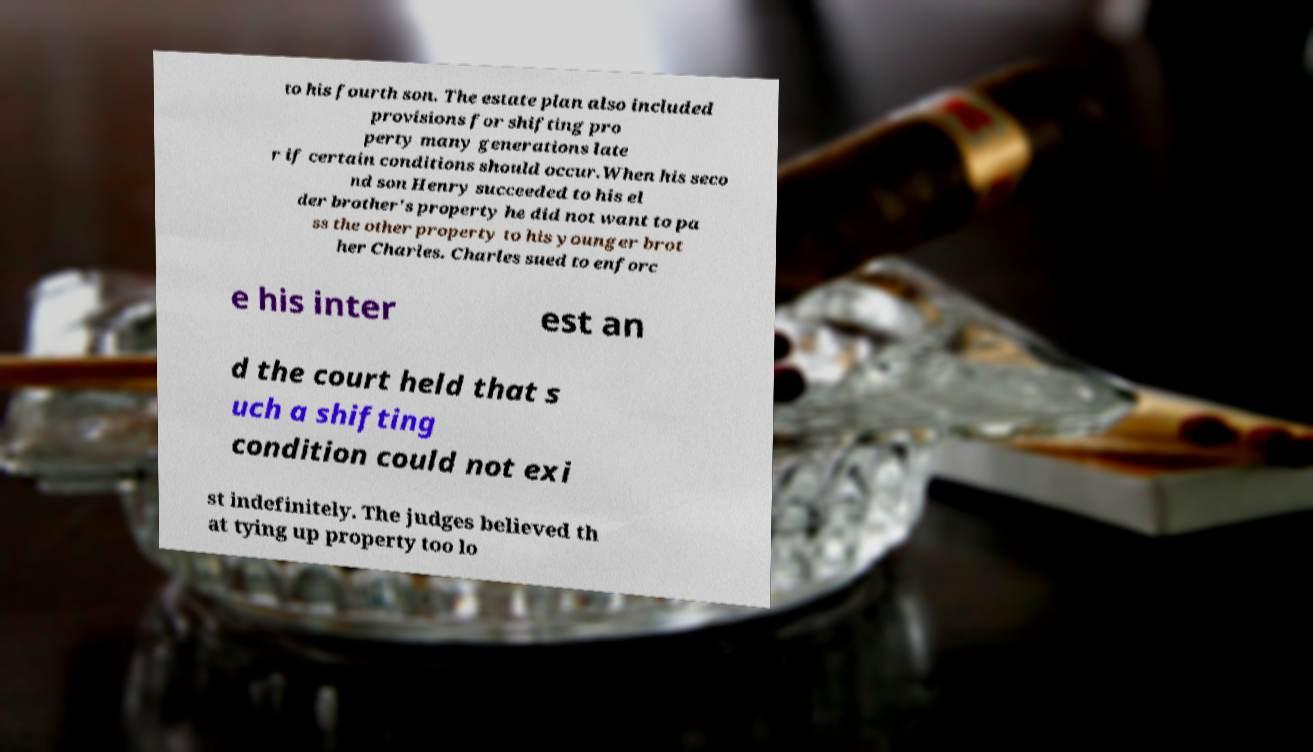I need the written content from this picture converted into text. Can you do that? to his fourth son. The estate plan also included provisions for shifting pro perty many generations late r if certain conditions should occur.When his seco nd son Henry succeeded to his el der brother's property he did not want to pa ss the other property to his younger brot her Charles. Charles sued to enforc e his inter est an d the court held that s uch a shifting condition could not exi st indefinitely. The judges believed th at tying up property too lo 